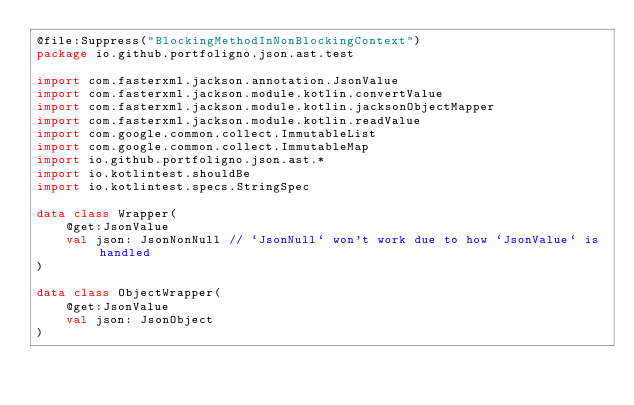<code> <loc_0><loc_0><loc_500><loc_500><_Kotlin_>@file:Suppress("BlockingMethodInNonBlockingContext")
package io.github.portfoligno.json.ast.test

import com.fasterxml.jackson.annotation.JsonValue
import com.fasterxml.jackson.module.kotlin.convertValue
import com.fasterxml.jackson.module.kotlin.jacksonObjectMapper
import com.fasterxml.jackson.module.kotlin.readValue
import com.google.common.collect.ImmutableList
import com.google.common.collect.ImmutableMap
import io.github.portfoligno.json.ast.*
import io.kotlintest.shouldBe
import io.kotlintest.specs.StringSpec

data class Wrapper(
    @get:JsonValue
    val json: JsonNonNull // `JsonNull` won't work due to how `JsonValue` is handled
)

data class ObjectWrapper(
    @get:JsonValue
    val json: JsonObject
)
</code> 